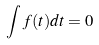<formula> <loc_0><loc_0><loc_500><loc_500>\int f ( t ) d t = 0</formula> 